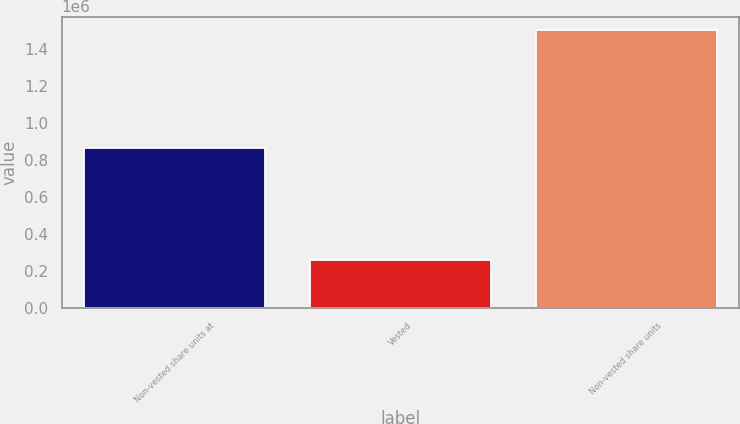Convert chart to OTSL. <chart><loc_0><loc_0><loc_500><loc_500><bar_chart><fcel>Non-vested share units at<fcel>Vested<fcel>Non-vested share units<nl><fcel>862734<fcel>259291<fcel>1.49822e+06<nl></chart> 